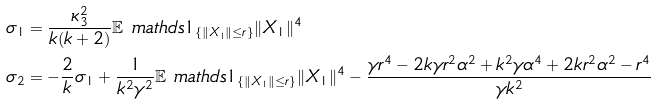<formula> <loc_0><loc_0><loc_500><loc_500>\sigma _ { 1 } & = \frac { \kappa _ { 3 } ^ { 2 } } { k ( k + 2 ) } \mathbb { E } \ m a t h d s { 1 } _ { \{ \| X _ { 1 } \| \leq r \} } \| X _ { 1 } \| ^ { 4 } \\ \sigma _ { 2 } & = - \frac { 2 } { k } \sigma _ { 1 } + \frac { 1 } { k ^ { 2 } \gamma ^ { 2 } } \mathbb { E } \ m a t h d s { 1 } _ { \{ \| X _ { 1 } \| \leq r \} } \| X _ { 1 } \| ^ { 4 } - \frac { \gamma r ^ { 4 } - 2 k \gamma r ^ { 2 } \alpha ^ { 2 } + k ^ { 2 } \gamma \alpha ^ { 4 } + 2 k r ^ { 2 } \alpha ^ { 2 } - r ^ { 4 } } { \gamma k ^ { 2 } }</formula> 